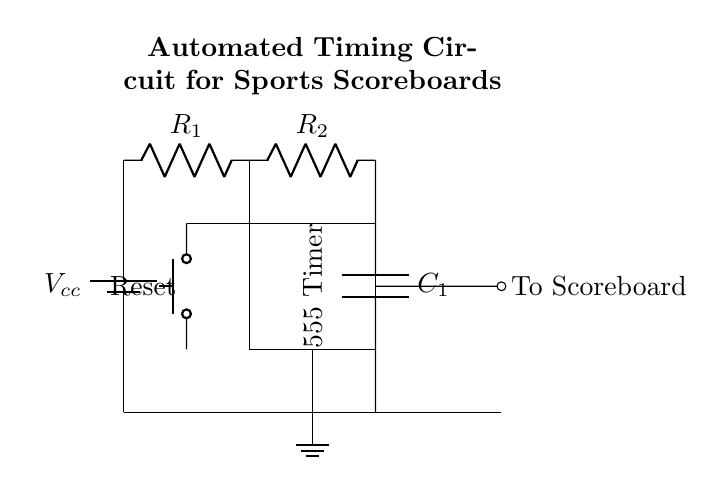what is the role of the 555 timer? The 555 timer is used in this circuit as a timing device, which generates time delays or pulses based on the resistor and capacitor values.
Answer: timing device what components are used for timing? The timing components in this circuit are a resistor R1, another resistor R2, and a capacitor C1, which work together to set the timing interval.
Answer: R1, R2, C1 how many resistors are present in this circuit? There are two resistors in the circuit labeled as R1 and R2, which are involved in shaping the timing characteristics.
Answer: two what is the function of the reset button? The reset button is used to reset the timer and the scoreboard to their initial states, allowing for a fresh start in the timing sequence.
Answer: reset timer how does the output connect to the scoreboard? The output from the 555 timer is connected to the scoreboard through a short connection labeled "To Scoreboard," which indicates where the timing signal is sent.
Answer: to scoreboard what type of circuit is this? This is an automated timing circuit, specifically designed for controlling time-related functions in sports scoreboards.
Answer: automated timing circuit what is the purpose of C1 in the circuit? Capacitor C1 is used to store charge, which helps to define the timing intervals by discharging at a specific rate in conjunction with the resistors.
Answer: timing intervals 